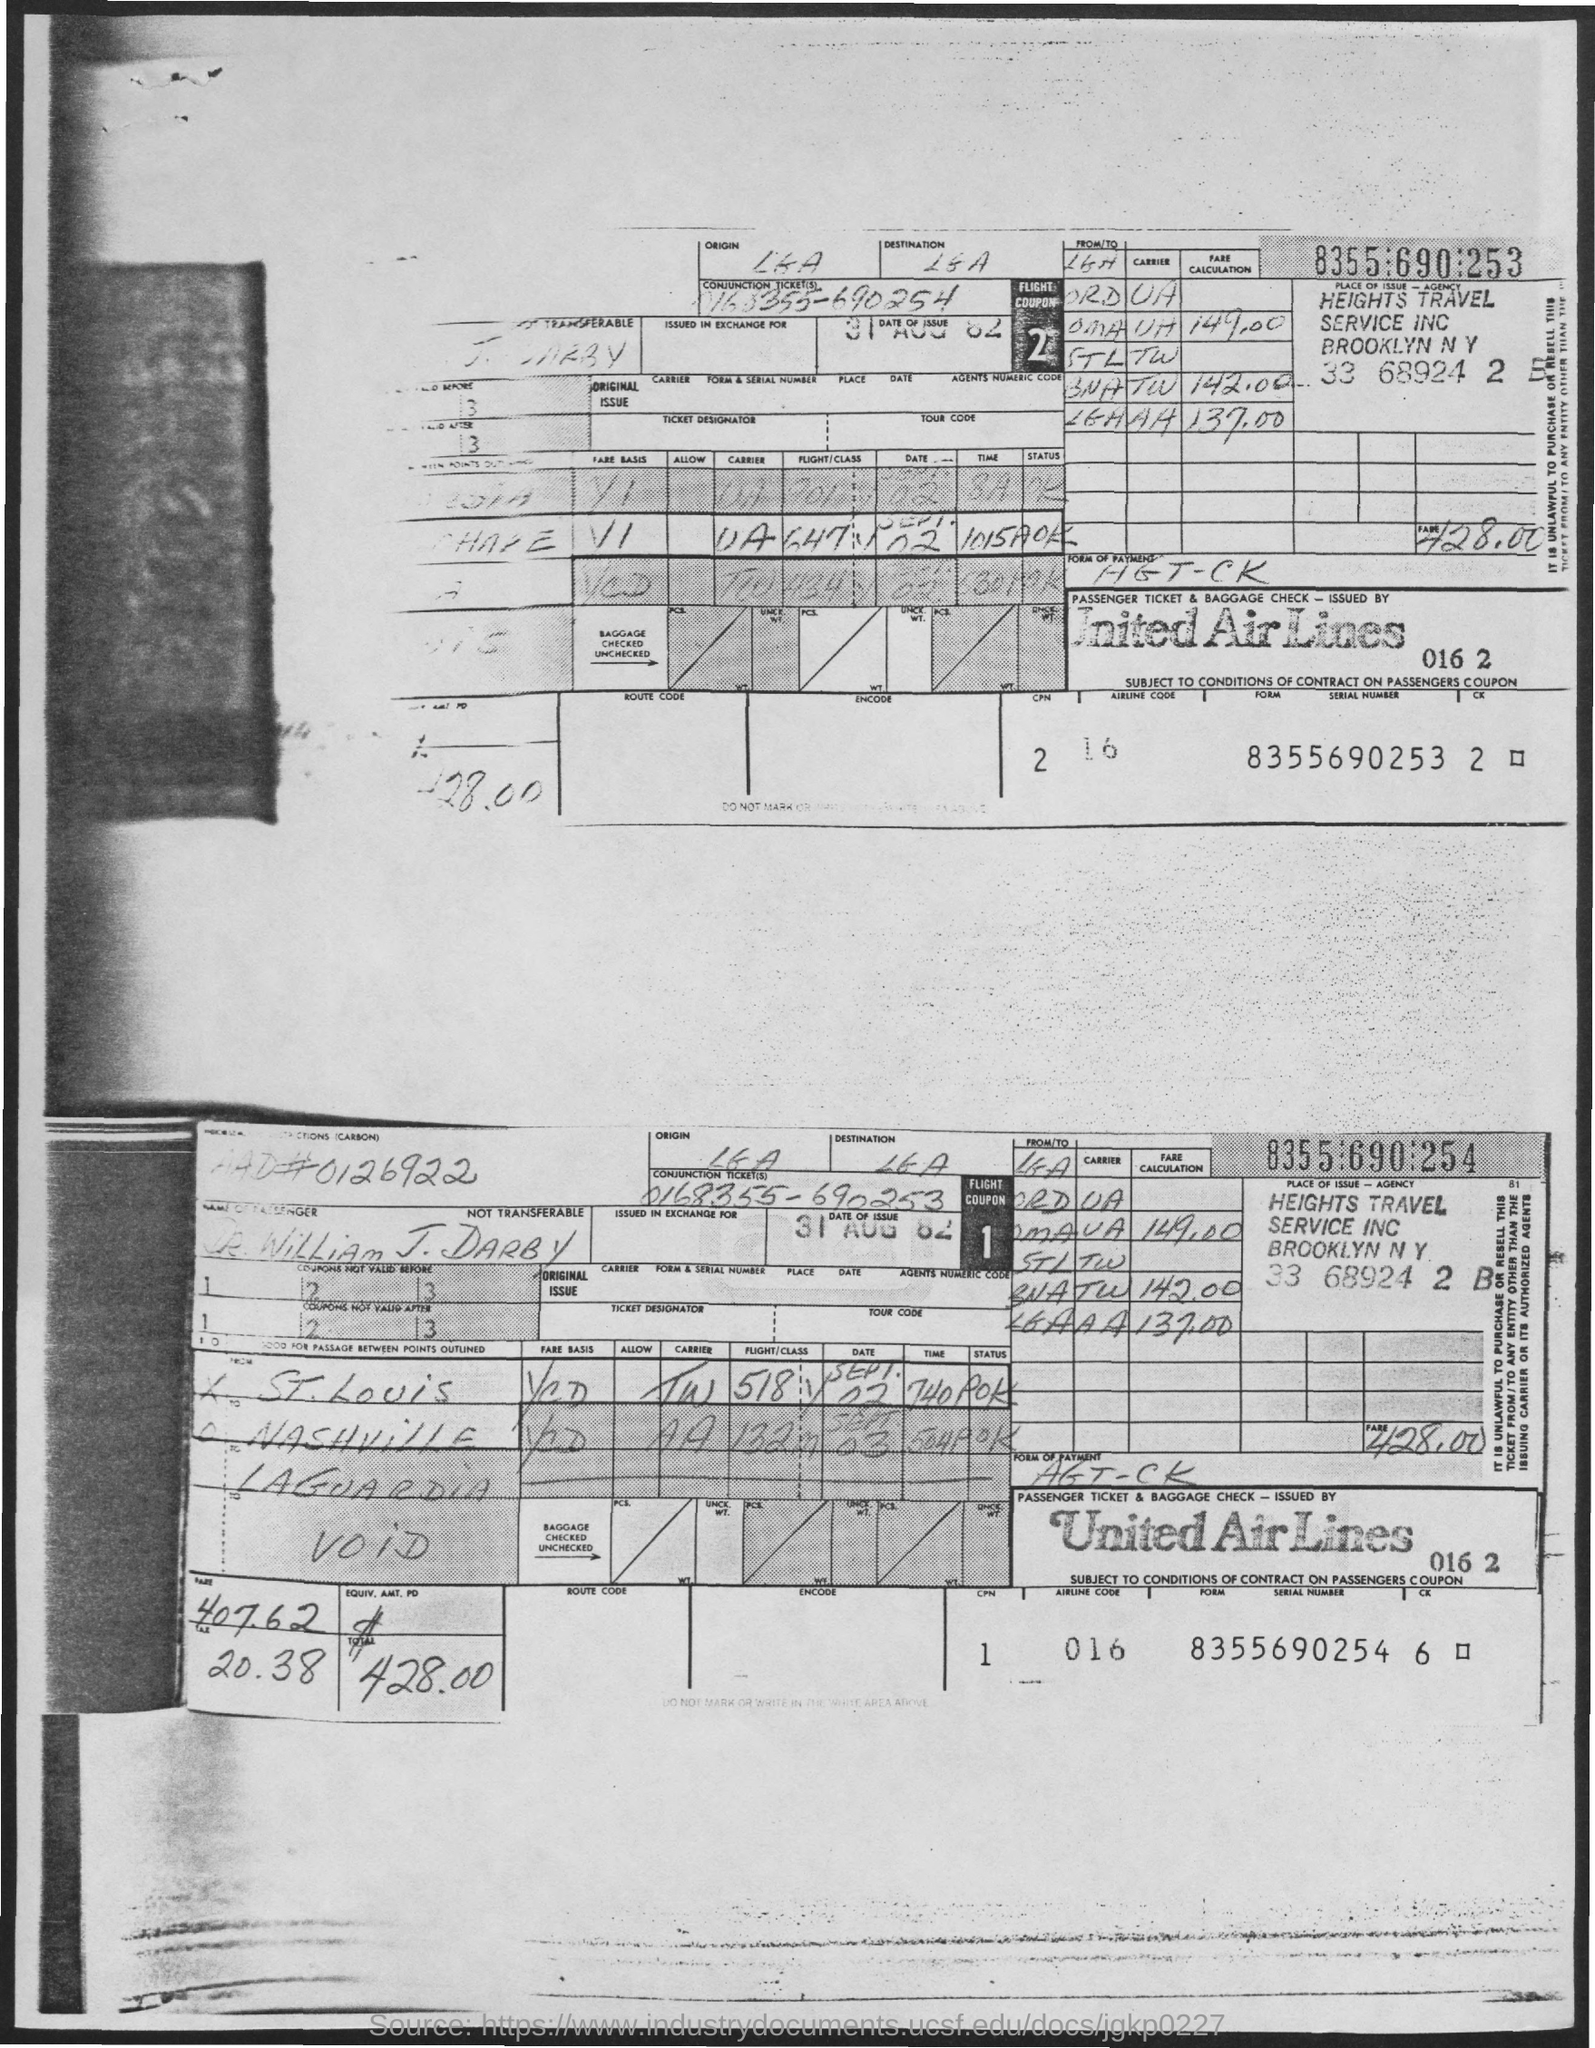What is the name of Airlines?
Your answer should be very brief. United Airlines. What is the date of the issue of both coupons?
Your answer should be compact. 31 aug 82. What is the serial number of Flight Coupon 1?
Your answer should be compact. 8355690254. What is the serial number of Flight Coupon 2?
Your answer should be compact. 8355690253. What is the form of payment?
Provide a short and direct response. Agt-ck. What is the Conjunction ticket number of Flight Coupon 1?
Make the answer very short. 0168355-690253. 